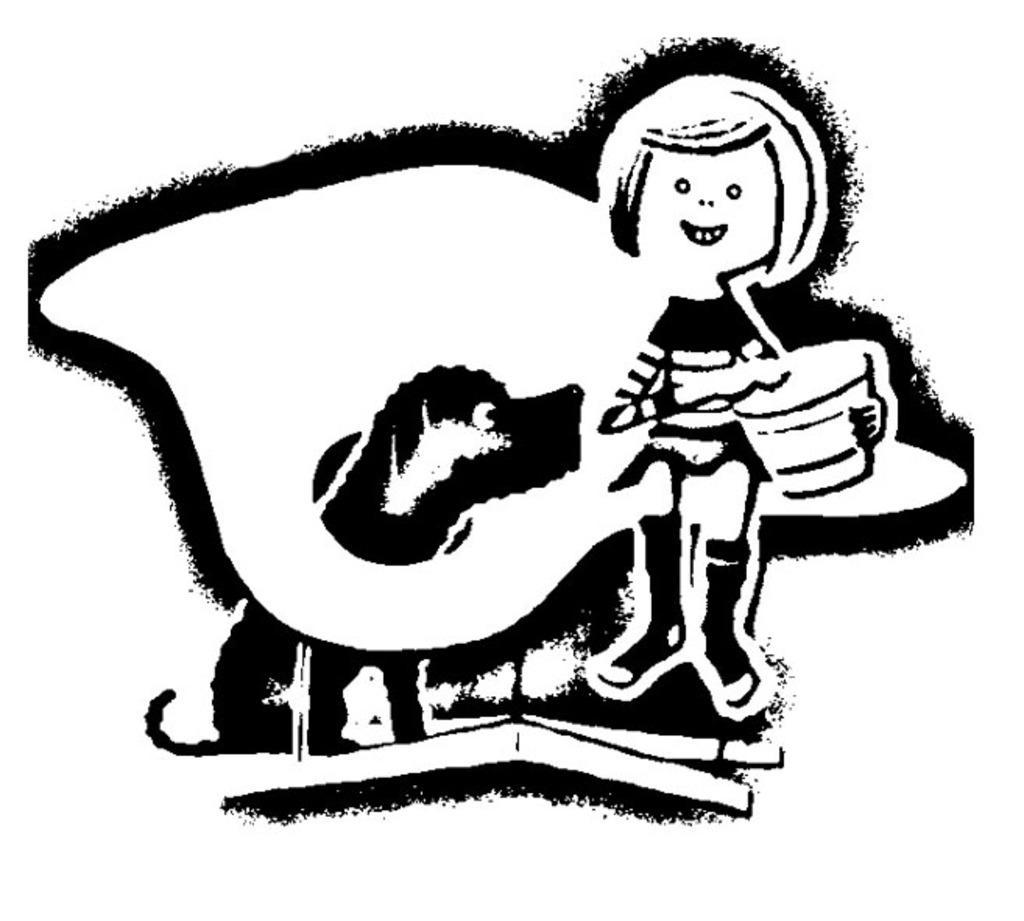In one or two sentences, can you explain what this image depicts? In this picture I can see cartoon image of a person and a dog and I can see white color background. 